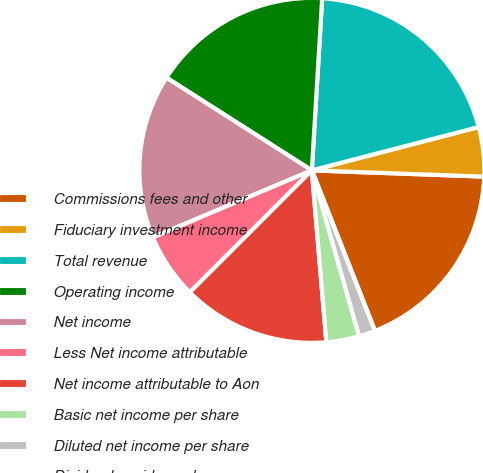<chart> <loc_0><loc_0><loc_500><loc_500><pie_chart><fcel>Commissions fees and other<fcel>Fiduciary investment income<fcel>Total revenue<fcel>Operating income<fcel>Net income<fcel>Less Net income attributable<fcel>Net income attributable to Aon<fcel>Basic net income per share<fcel>Diluted net income per share<fcel>Dividends paid per share<nl><fcel>18.46%<fcel>4.62%<fcel>20.0%<fcel>16.92%<fcel>15.38%<fcel>6.15%<fcel>13.85%<fcel>3.08%<fcel>1.54%<fcel>0.0%<nl></chart> 